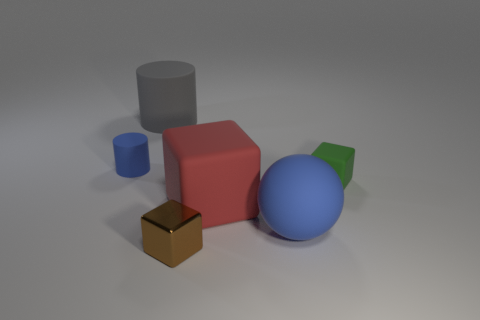Add 4 brown shiny cubes. How many objects exist? 10 Subtract all cylinders. How many objects are left? 4 Subtract 0 green cylinders. How many objects are left? 6 Subtract all red blocks. Subtract all tiny brown cubes. How many objects are left? 4 Add 6 big cylinders. How many big cylinders are left? 7 Add 6 blue rubber balls. How many blue rubber balls exist? 7 